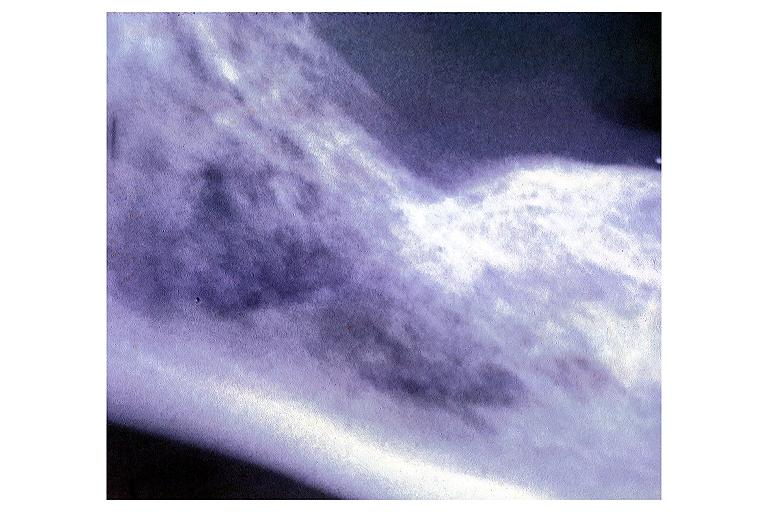what is present?
Answer the question using a single word or phrase. Oral 